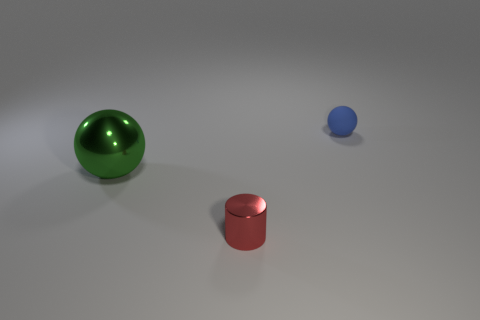Are there any large brown metal things of the same shape as the green thing? Upon reviewing the image, there are no brown objects present. The objects that can be seen are a green sphere, a red cylinder, and a small blue sphere. None of the objects share their shape with another of a different color. 